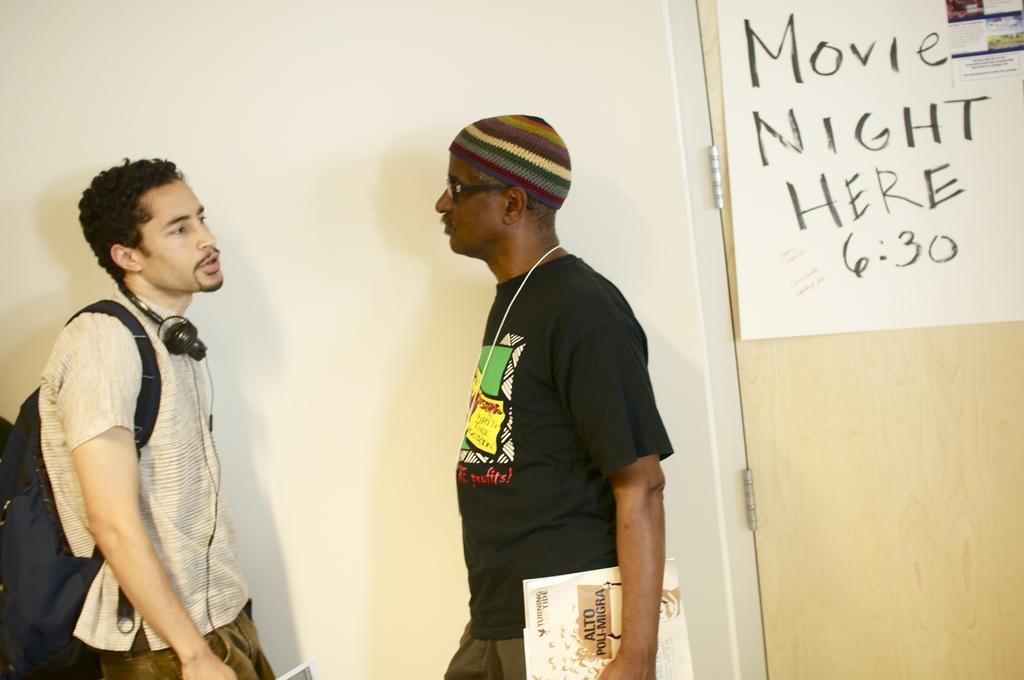Can you describe this image briefly? There are two men standing in the foreground area of the image, it seems like a chart on the door in the background. 